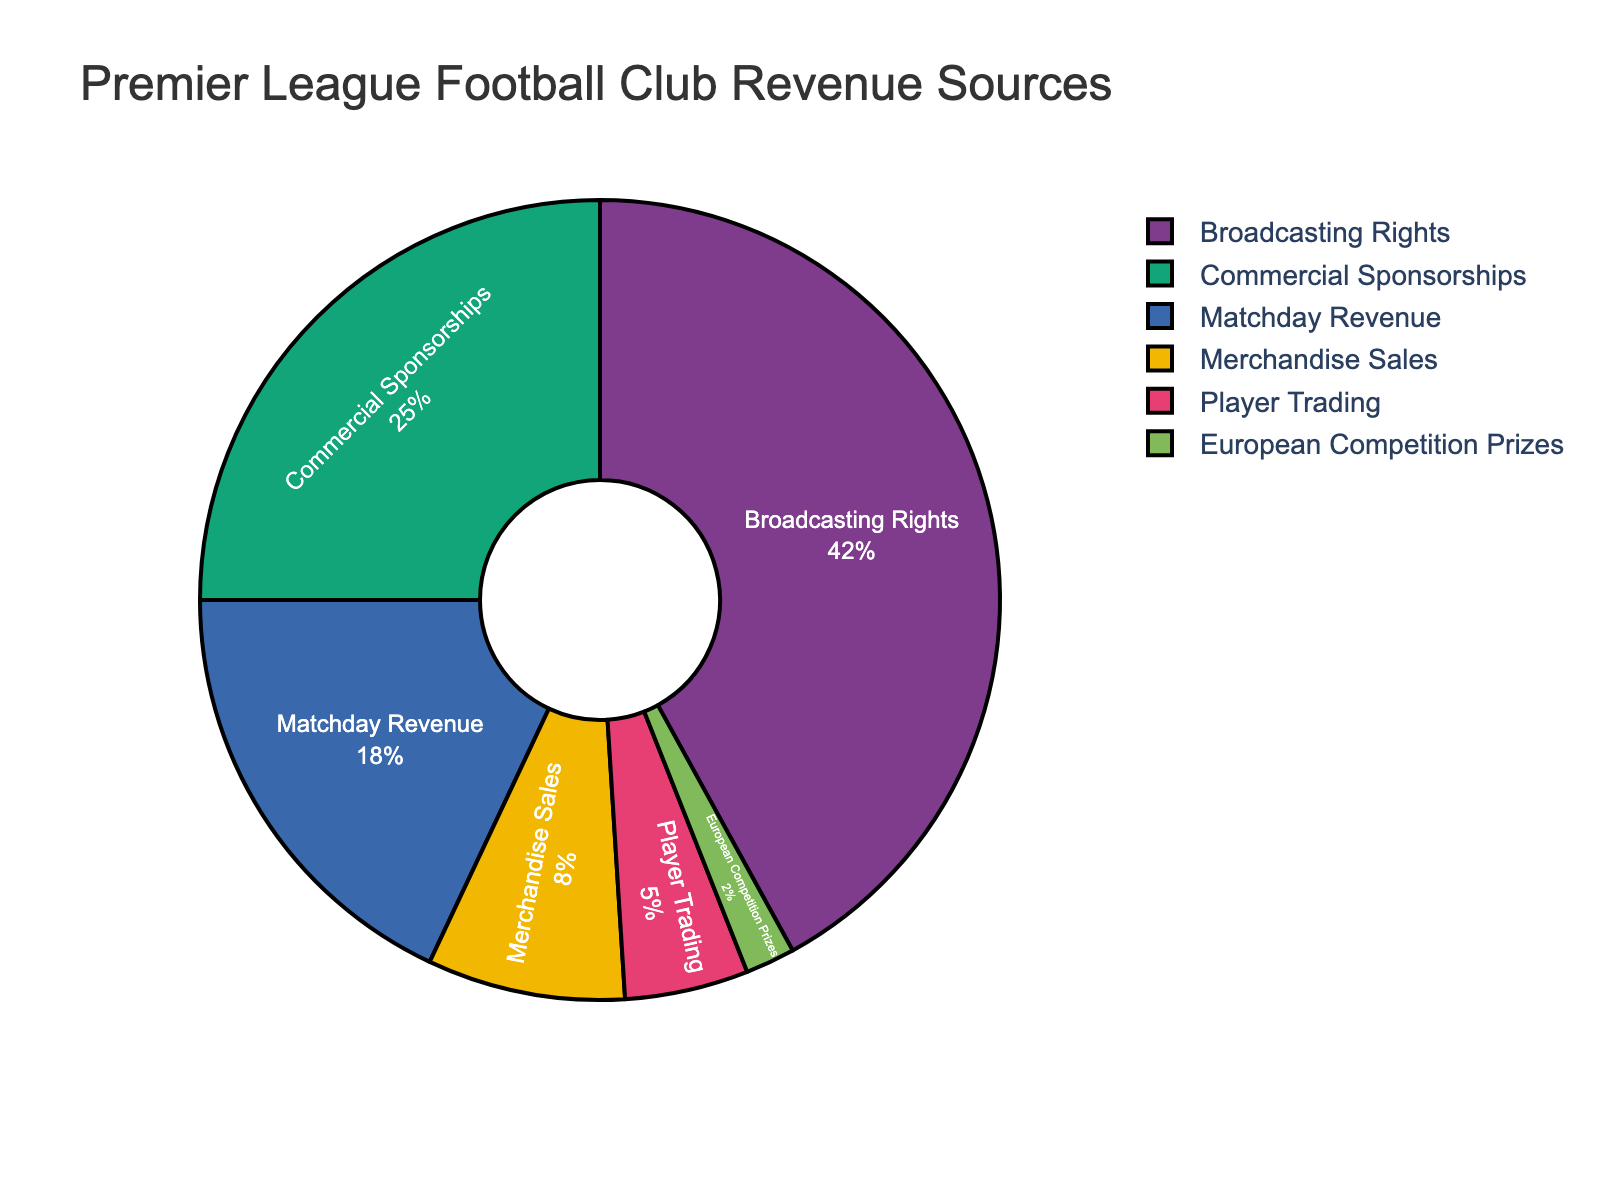What's the largest revenue source for Premier League football clubs? The largest revenue source can be identified by finding the category with the highest percentage on the pie chart. Broadcasting Rights has the highest percentage at 42%.
Answer: Broadcasting Rights Which revenue source contributes the least to the total revenue? The smallest revenue source can be determined by identifying the category with the lowest percentage on the pie chart. European Competition Prizes contributes the least, with only 2%.
Answer: European Competition Prizes What is the combined percentage of Matchday Revenue and Merchandise Sales? Add the percentages of Matchday Revenue and Merchandise Sales. Matchday Revenue is 18% and Merchandise Sales is 8%, so 18% + 8% = 26%.
Answer: 26% How does Commercial Sponsorship compare to Player Trading in terms of percentage? Compare the percentages of Commercial Sponsorships and Player Trading. Commercial Sponsorships have 25%, whereas Player Trading has 5%. 25% is greater than 5%.
Answer: Commercial Sponsorships generate a higher percentage than Player Trading Which color represents the Broadcasting Rights revenue source? The visual attribute for Broadcasting Rights can be identified by looking at its color in the pie chart (assumed from the qualitative colors used). Suppose Broadcasting Rights is represented by the central blue region.
Answer: Blue What percentage more does Broadcasting Rights contribute compared to Player Trading? Subtract the percentage of Player Trading from Broadcasting Rights. Broadcasting Rights is 42%, Player Trading is 5%. So, 42% - 5% = 37%.
Answer: 37% What are the second and third largest revenue sources? The second and third largest revenue sources are identified by comparing all percentages, with the highest being Broadcasting Rights at 42%. The next highest are Commercial Sponsorships at 25% and Matchday Revenue at 18%.
Answer: Commercial Sponsorships and Matchday Revenue How much more significant is Broadcasting Rights compared to Merchandise Sales? Subtract the percentage of Merchandise Sales from Broadcasting Rights. Broadcasting Rights is 42%, Merchandise Sales is 8%. Thus, 42% - 8% = 34%.
Answer: 34% What is the combined percentage of Player Trading and European Competition Prizes revenue sources? Add the percentages of Player Trading and European Competition Prizes. Player Trading contributes 5% and European Competition Prizes contribute 2%, so 5% + 2% = 7%.
Answer: 7% What fraction of the revenue comes from sources other than Broadcasting Rights? Subtract the percentage of Broadcasting Rights from the total (100%). 100% - 42% = 58%.
Answer: 58% 